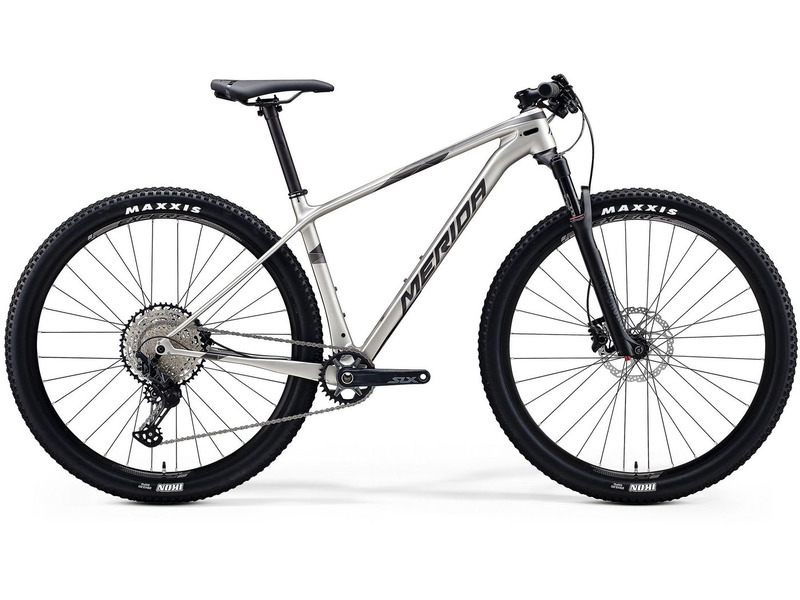Can you suggest some popular trail destinations where this bike would perform exceptionally well? This mountain bike, equipped with features tailored for off-road cycling, would perform exceptionally well in several renowned trail destinations. Some suggestions include:

1. **Moab, Utah (USA)**: Famous for its vast network of trails like the Slickrock Trail and Porcupine Rim, offering challenging terrain and breathtaking scenery.

2. **Whistler Mountain Bike Park, British Columbia (Canada)**: Known for its diverse range of trails that suit various skill levels, from beginner to expert, and its extensive lift-accessed downhill runs.

3. **Finale Ligure (Italy)**: Offers a variety of trails with stunning Mediterranean views, catering to both cross-country and enduro riders.

4. **Rotorua (New Zealand)**: Home to the Whakarewarewa Forest, which boasts an extensive trail network with everything from flowing singletracks to technical descents.

5. **Alpes-Maritimes (France)**: Known for its picturesque trails, rugged terrain, and the infamous Trans-Provence race route.

These destinations offer a mix of technical trails, scenic views, and varied terrains perfect for getting the most out of your mountain bike. What are some essential accessories to carry when riding this mountain bike on such trails? When riding this mountain bike on off-road trails, it’s crucial to carry some essential accessories to ensure safety and preparedness. Here are some must-have items:

1. **Helmet**: Always wear a properly fitting helmet to protect your head in case of falls or collisions.

2. **Gloves**: Cycling gloves improve grip and protect your hands from blisters and injuries.

3. **Hydration System**: A water bottle or hydration pack to stay hydrated during long rides.

4. **Repair Kit**: Including a multi-tool, tire levers, spare tubes, a patch kit, and a hand pump or CO2 inflator for on-the-trail repairs.

5. **First Aid Kit**: A small kit with bandages, antiseptic wipes, and other basic first aid supplies.

6. **Chain Lube**: To keep your drivetrain running smoothly, especially in muddy or dusty conditions.

7. **Compact Multi-Tool**: Essential for on-the-go adjustments and repairs.

8. **Snack/Energy Bars**: For quick energy boosts during extended rides.

9. **Protective Eyewear**: To shield your eyes from dust, debris, and sunlight.

10. **Bike Lights**: In case you end up riding in low-light conditions or after dark.

Having these items will help ensure that you’re prepared for various situations and can enjoy your trail riding experience to the fullest. 